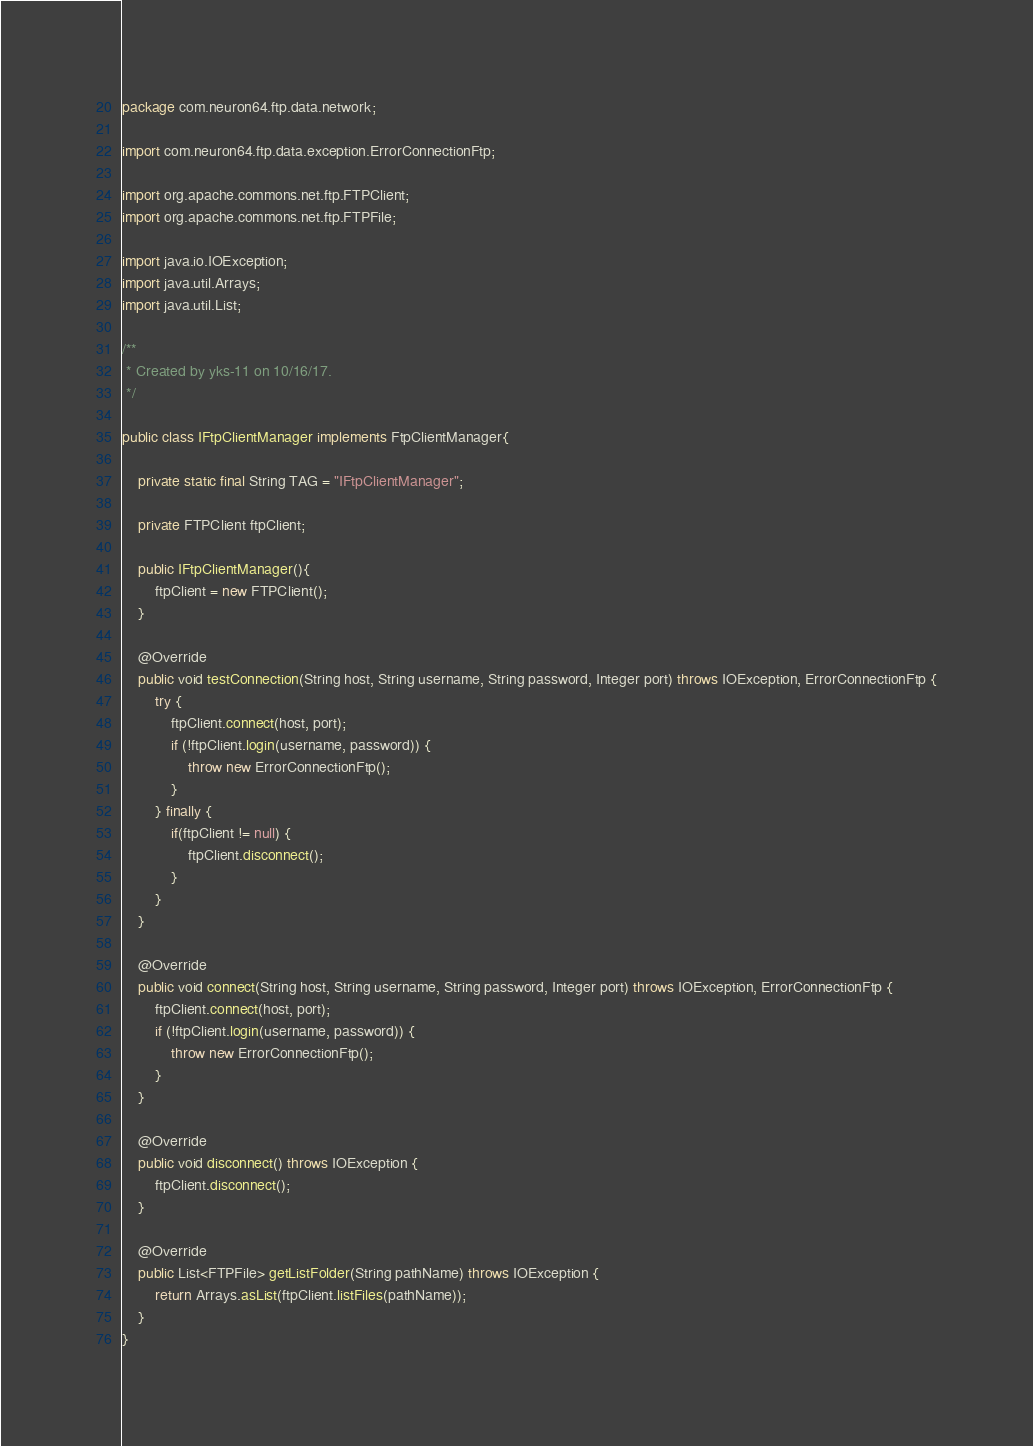Convert code to text. <code><loc_0><loc_0><loc_500><loc_500><_Java_>package com.neuron64.ftp.data.network;

import com.neuron64.ftp.data.exception.ErrorConnectionFtp;

import org.apache.commons.net.ftp.FTPClient;
import org.apache.commons.net.ftp.FTPFile;

import java.io.IOException;
import java.util.Arrays;
import java.util.List;

/**
 * Created by yks-11 on 10/16/17.
 */

public class IFtpClientManager implements FtpClientManager{

    private static final String TAG = "IFtpClientManager";

    private FTPClient ftpClient;

    public IFtpClientManager(){
        ftpClient = new FTPClient();
    }

    @Override
    public void testConnection(String host, String username, String password, Integer port) throws IOException, ErrorConnectionFtp {
        try {
            ftpClient.connect(host, port);
            if (!ftpClient.login(username, password)) {
                throw new ErrorConnectionFtp();
            }
        } finally {
            if(ftpClient != null) {
                ftpClient.disconnect();
            }
        }
    }

    @Override
    public void connect(String host, String username, String password, Integer port) throws IOException, ErrorConnectionFtp {
        ftpClient.connect(host, port);
        if (!ftpClient.login(username, password)) {
            throw new ErrorConnectionFtp();
        }
    }

    @Override
    public void disconnect() throws IOException {
        ftpClient.disconnect();
    }

    @Override
    public List<FTPFile> getListFolder(String pathName) throws IOException {
        return Arrays.asList(ftpClient.listFiles(pathName));
    }
}
</code> 